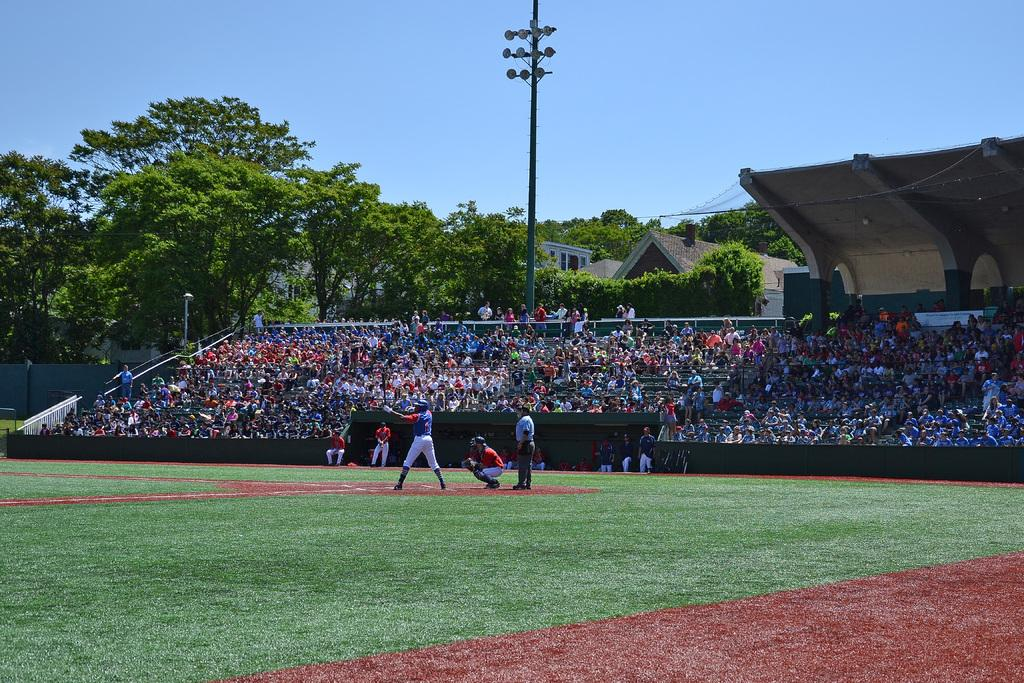What is happening on the ground in the image? There are people on the ground in the image. What can be seen in the background of the image? In the background of the image, there is a fence, people, poles, a shed, houses, trees, and the sky. Can you describe the fence in the background? The fence is visible in the background of the image. How many types of structures are visible in the background? There are at least four types of structures visible in the background: a shed, houses, poles, and a fence. What type of natural environment is visible in the background? Trees and the sky are visible in the background of the image. How many pies are being served on the patch of grass in the image? There are no pies or patches of grass visible in the image; the image features people on the ground and various structures and natural elements in the background. What is the health status of the people in the image? The image does not provide any information about the health status of the people; it only shows their presence and activities. 